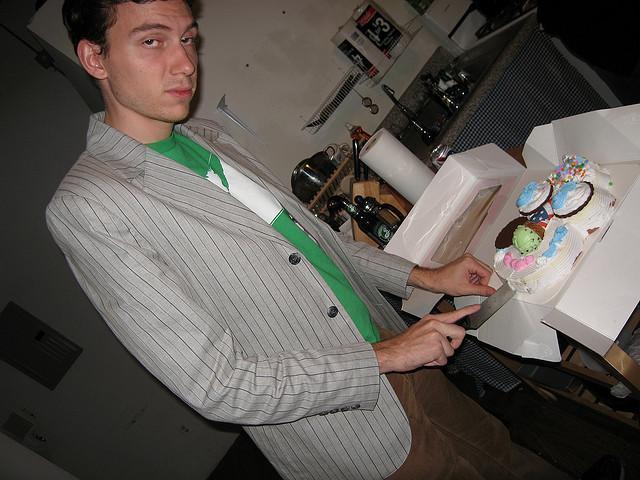What is inside the cake being cut?
From the following set of four choices, select the accurate answer to respond to the question.
Options: Marshmallows, bread, ice cream, angel food. Ice cream. 